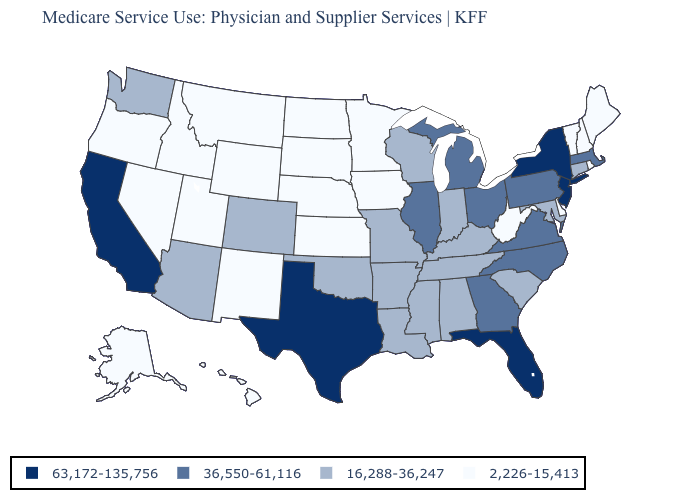What is the value of Wisconsin?
Be succinct. 16,288-36,247. Name the states that have a value in the range 2,226-15,413?
Quick response, please. Alaska, Delaware, Hawaii, Idaho, Iowa, Kansas, Maine, Minnesota, Montana, Nebraska, Nevada, New Hampshire, New Mexico, North Dakota, Oregon, Rhode Island, South Dakota, Utah, Vermont, West Virginia, Wyoming. Among the states that border Oregon , which have the lowest value?
Write a very short answer. Idaho, Nevada. What is the value of Wyoming?
Quick response, please. 2,226-15,413. Does New York have a lower value than Nevada?
Be succinct. No. Does Maryland have a lower value than Massachusetts?
Answer briefly. Yes. What is the value of Virginia?
Keep it brief. 36,550-61,116. Which states have the lowest value in the USA?
Concise answer only. Alaska, Delaware, Hawaii, Idaho, Iowa, Kansas, Maine, Minnesota, Montana, Nebraska, Nevada, New Hampshire, New Mexico, North Dakota, Oregon, Rhode Island, South Dakota, Utah, Vermont, West Virginia, Wyoming. Among the states that border Virginia , does Maryland have the highest value?
Write a very short answer. No. What is the lowest value in states that border New Hampshire?
Concise answer only. 2,226-15,413. Does South Carolina have the same value as South Dakota?
Give a very brief answer. No. What is the value of Kentucky?
Answer briefly. 16,288-36,247. Name the states that have a value in the range 16,288-36,247?
Answer briefly. Alabama, Arizona, Arkansas, Colorado, Connecticut, Indiana, Kentucky, Louisiana, Maryland, Mississippi, Missouri, Oklahoma, South Carolina, Tennessee, Washington, Wisconsin. What is the lowest value in the USA?
Keep it brief. 2,226-15,413. What is the value of Tennessee?
Quick response, please. 16,288-36,247. 